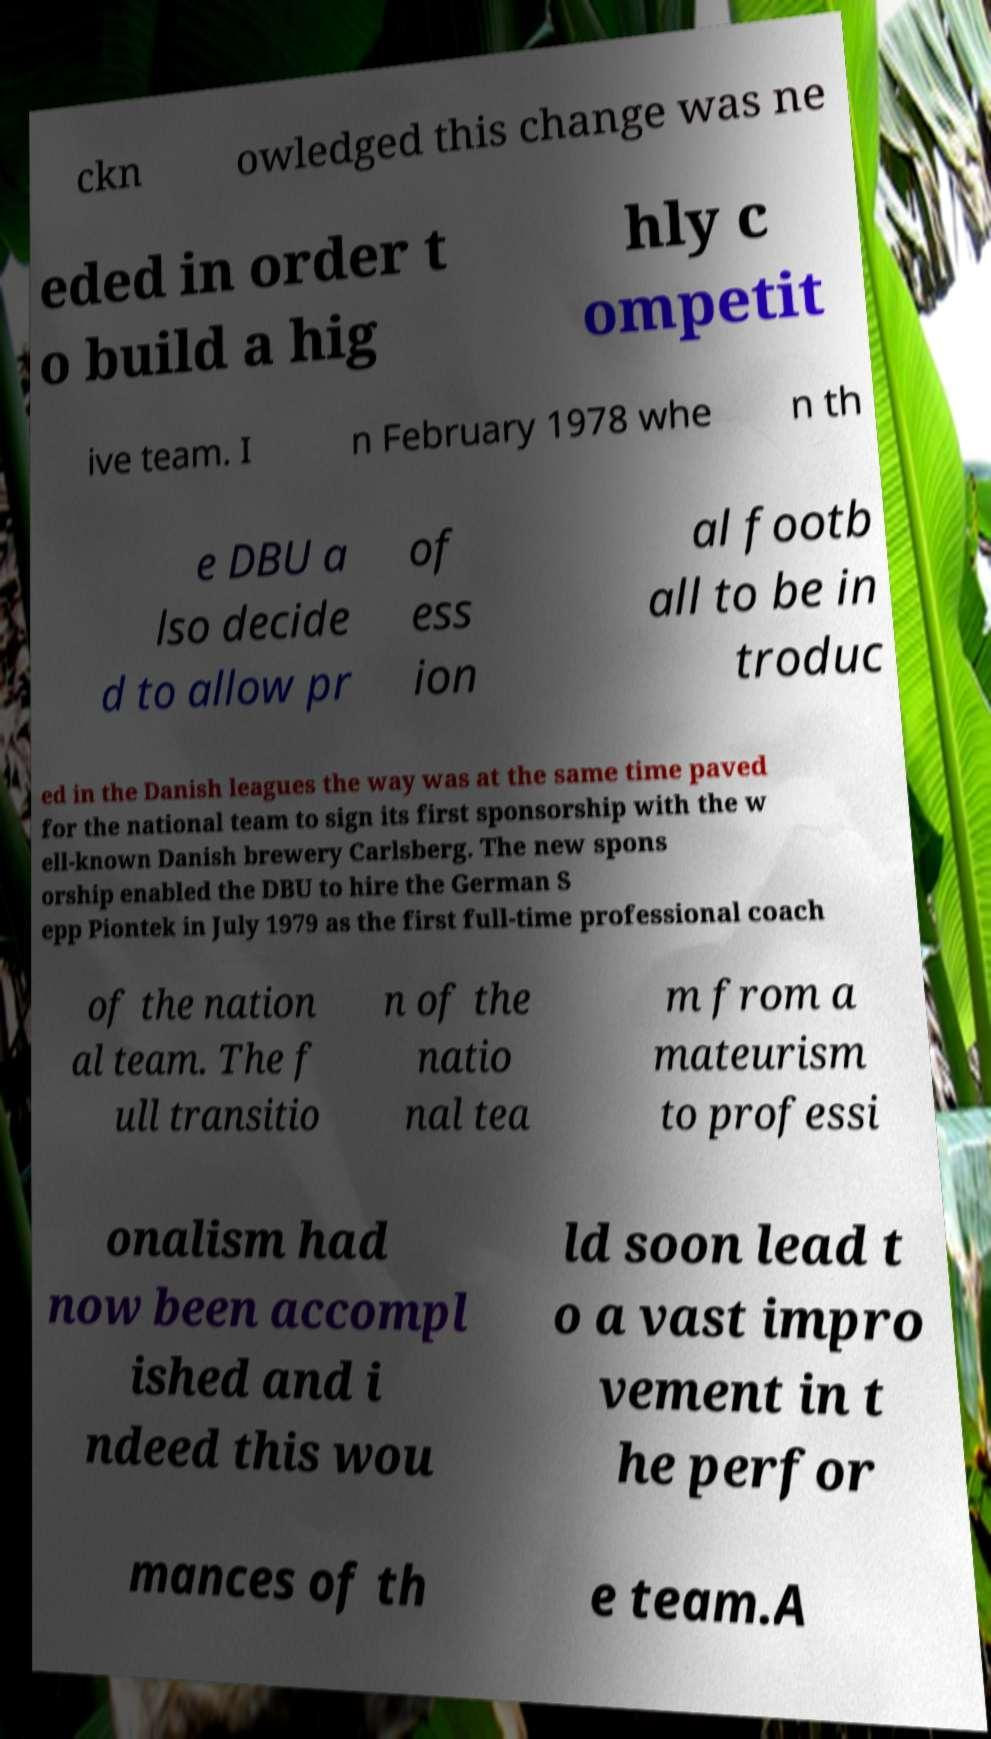Could you assist in decoding the text presented in this image and type it out clearly? ckn owledged this change was ne eded in order t o build a hig hly c ompetit ive team. I n February 1978 whe n th e DBU a lso decide d to allow pr of ess ion al footb all to be in troduc ed in the Danish leagues the way was at the same time paved for the national team to sign its first sponsorship with the w ell-known Danish brewery Carlsberg. The new spons orship enabled the DBU to hire the German S epp Piontek in July 1979 as the first full-time professional coach of the nation al team. The f ull transitio n of the natio nal tea m from a mateurism to professi onalism had now been accompl ished and i ndeed this wou ld soon lead t o a vast impro vement in t he perfor mances of th e team.A 